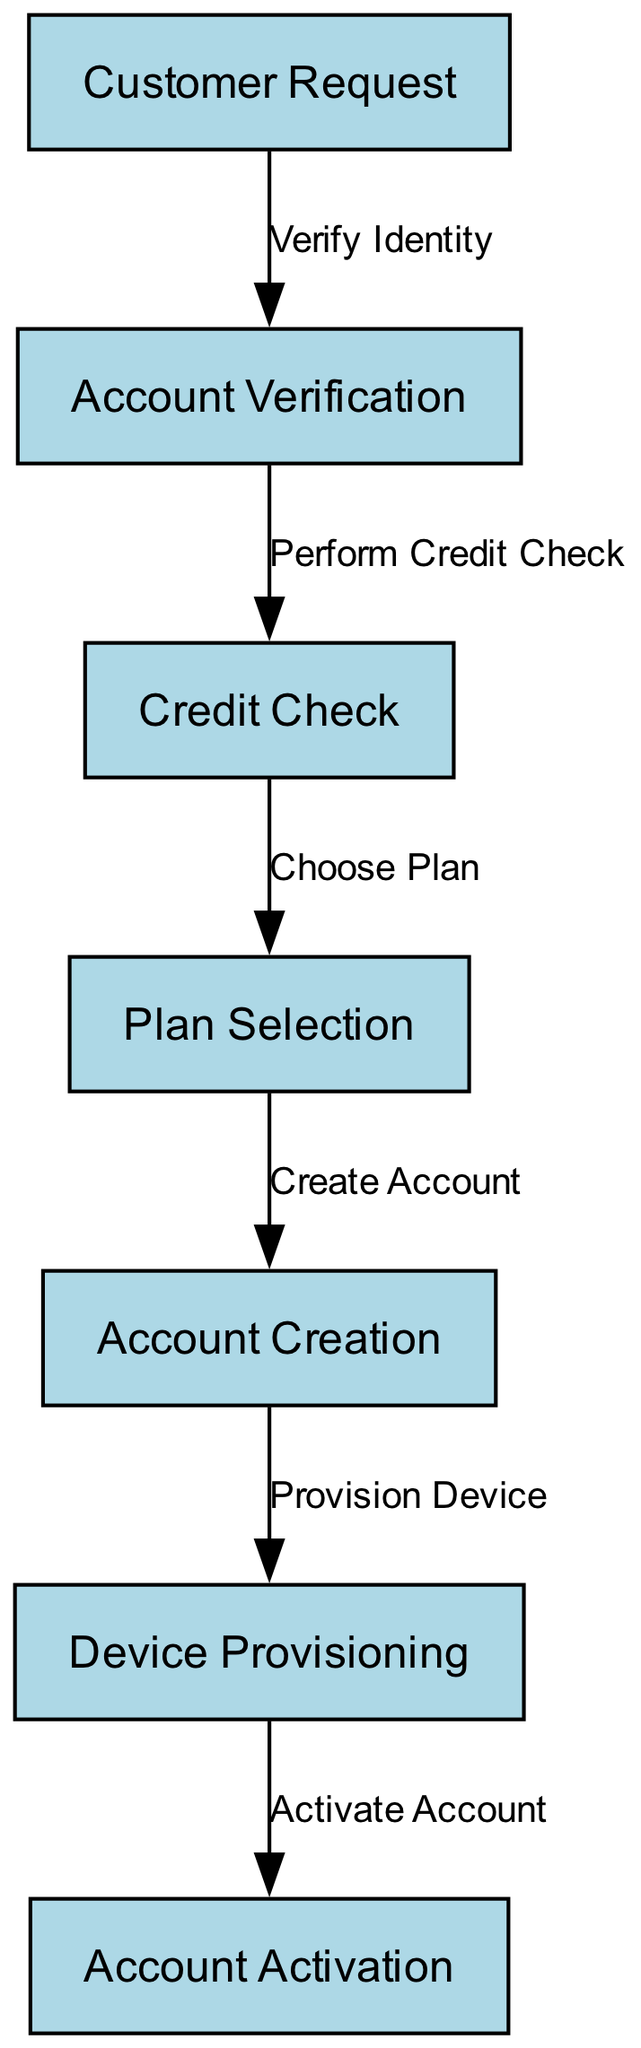What is the first node in the workflow? The first node is labeled "Customer Request". It is the starting point of the workflow as indicated by its position at the top of the diagram.
Answer: Customer Request How many nodes are there in total? To find the total number of nodes, we count the list of nodes provided in the data. There are seven nodes present in the diagram.
Answer: 7 What label is associated with the edge from "Account Verification"? The edge from "Account Verification" goes to "Credit Check" and is labeled "Perform Credit Check". This label indicates the action taken between these two steps.
Answer: Perform Credit Check What is the last step in the workflow? The last step in the workflow is labeled "Account Activation". It is the final node in the sequence, indicating the end of the process.
Answer: Account Activation Which step follows "Device Provisioning"? Following "Device Provisioning", the next step is "Account Activation". This connection shows the progression of activities that occurs in the workflow after provisioning.
Answer: Account Activation How many edges are there connecting the nodes? The edges represent the connections between the nodes. By counting the edges specified, we determine there are six edges connecting the nodes in the workflow diagram.
Answer: 6 What two nodes are connected with an edge labeled "Choose Plan"? The edge labeled "Choose Plan" connects the nodes "Credit Check" and "Plan Selection". This indicates that after performing a credit check, the customer chooses their plan.
Answer: Credit Check and Plan Selection Which action comes directly after "Create Account"? The action that comes directly after "Create Account" is "Provision Device". This indicates the next step following the account's creation.
Answer: Provision Device 